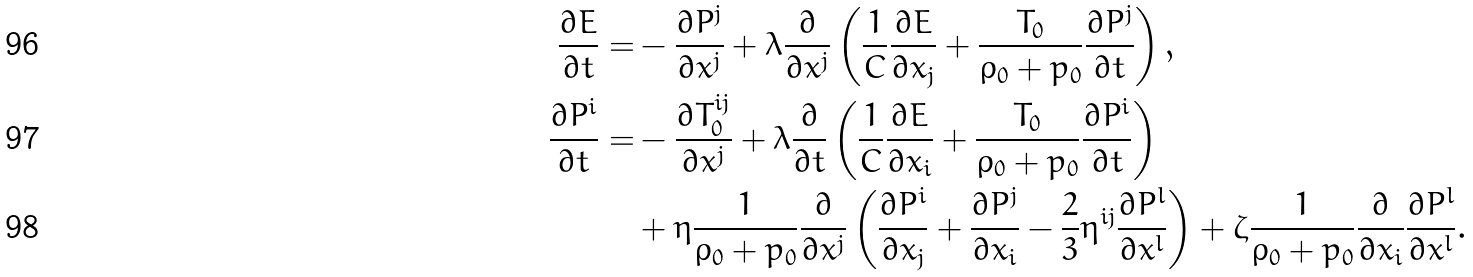<formula> <loc_0><loc_0><loc_500><loc_500>\frac { \partial E } { \partial t } = & - \frac { \partial P ^ { j } } { \partial x ^ { j } } + \lambda \frac { \partial } { \partial x ^ { j } } \left ( \frac { 1 } { C } \frac { \partial E } { \partial x _ { j } } + \frac { T _ { 0 } } { \rho _ { 0 } + p _ { 0 } } \frac { \partial P ^ { j } } { \partial t } \right ) , \\ \frac { \partial P ^ { i } } { \partial t } = & - \frac { \partial T _ { 0 } ^ { i j } } { \partial x ^ { j } } + \lambda \frac { \partial } { \partial t } \left ( \frac { 1 } { C } \frac { \partial E } { \partial x _ { i } } + \frac { T _ { 0 } } { \rho _ { 0 } + p _ { 0 } } \frac { \partial P ^ { i } } { \partial t } \right ) \\ & + \eta \frac { 1 } { \rho _ { 0 } + p _ { 0 } } \frac { \partial } { \partial x ^ { j } } \left ( \frac { \partial P ^ { i } } { \partial x _ { j } } + \frac { \partial P ^ { j } } { \partial x _ { i } } - \frac { 2 } { 3 } \eta ^ { i j } \frac { \partial P ^ { l } } { \partial x ^ { l } } \right ) + \zeta \frac { 1 } { \rho _ { 0 } + p _ { 0 } } \frac { \partial } { \partial x _ { i } } \frac { \partial P ^ { l } } { \partial x ^ { l } } .</formula> 